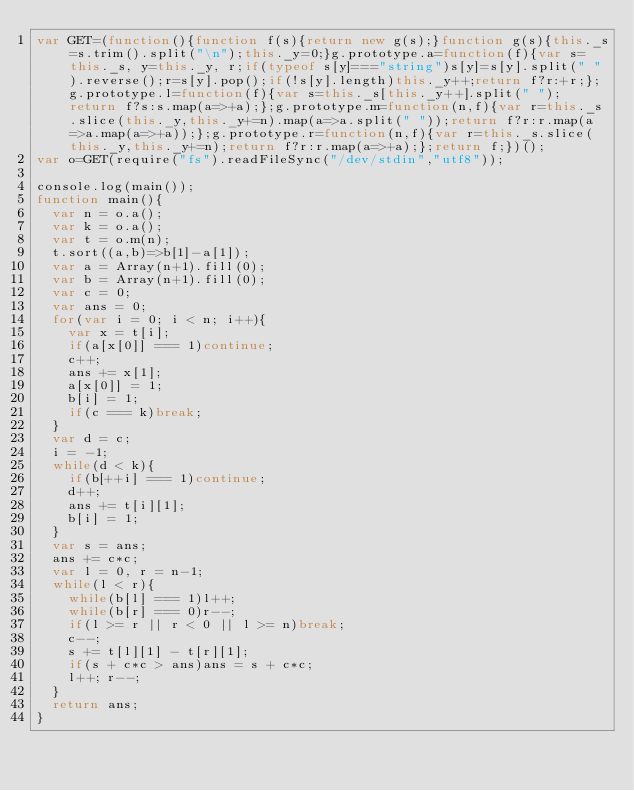Convert code to text. <code><loc_0><loc_0><loc_500><loc_500><_JavaScript_>var GET=(function(){function f(s){return new g(s);}function g(s){this._s=s.trim().split("\n");this._y=0;}g.prototype.a=function(f){var s=this._s, y=this._y, r;if(typeof s[y]==="string")s[y]=s[y].split(" ").reverse();r=s[y].pop();if(!s[y].length)this._y++;return f?r:+r;};g.prototype.l=function(f){var s=this._s[this._y++].split(" ");return f?s:s.map(a=>+a);};g.prototype.m=function(n,f){var r=this._s.slice(this._y,this._y+=n).map(a=>a.split(" "));return f?r:r.map(a=>a.map(a=>+a));};g.prototype.r=function(n,f){var r=this._s.slice(this._y,this._y+=n);return f?r:r.map(a=>+a);};return f;})();
var o=GET(require("fs").readFileSync("/dev/stdin","utf8"));

console.log(main());
function main(){
  var n = o.a();
  var k = o.a();
  var t = o.m(n);
  t.sort((a,b)=>b[1]-a[1]);
  var a = Array(n+1).fill(0);
  var b = Array(n+1).fill(0);
  var c = 0;
  var ans = 0;
  for(var i = 0; i < n; i++){
    var x = t[i];
    if(a[x[0]] === 1)continue;
    c++;
    ans += x[1];
    a[x[0]] = 1;
    b[i] = 1;
    if(c === k)break;
  }
  var d = c;
  i = -1;
  while(d < k){
    if(b[++i] === 1)continue;
    d++;
    ans += t[i][1];
    b[i] = 1;
  }
  var s = ans;
  ans += c*c;
  var l = 0, r = n-1;
  while(l < r){
    while(b[l] === 1)l++;
    while(b[r] === 0)r--;
    if(l >= r || r < 0 || l >= n)break;
    c--;
    s += t[l][1] - t[r][1];
    if(s + c*c > ans)ans = s + c*c;
    l++; r--;
  }
  return ans;
}</code> 